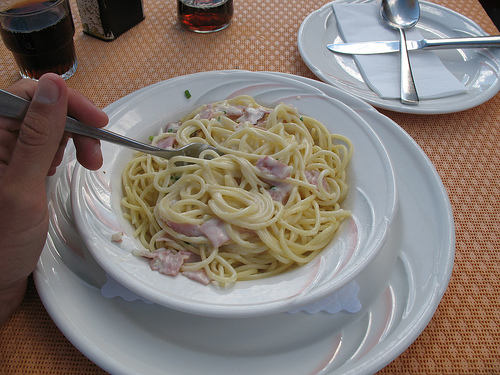<image>
Is the man on the spoon? No. The man is not positioned on the spoon. They may be near each other, but the man is not supported by or resting on top of the spoon. Is the drink to the left of the napkin? Yes. From this viewpoint, the drink is positioned to the left side relative to the napkin. 